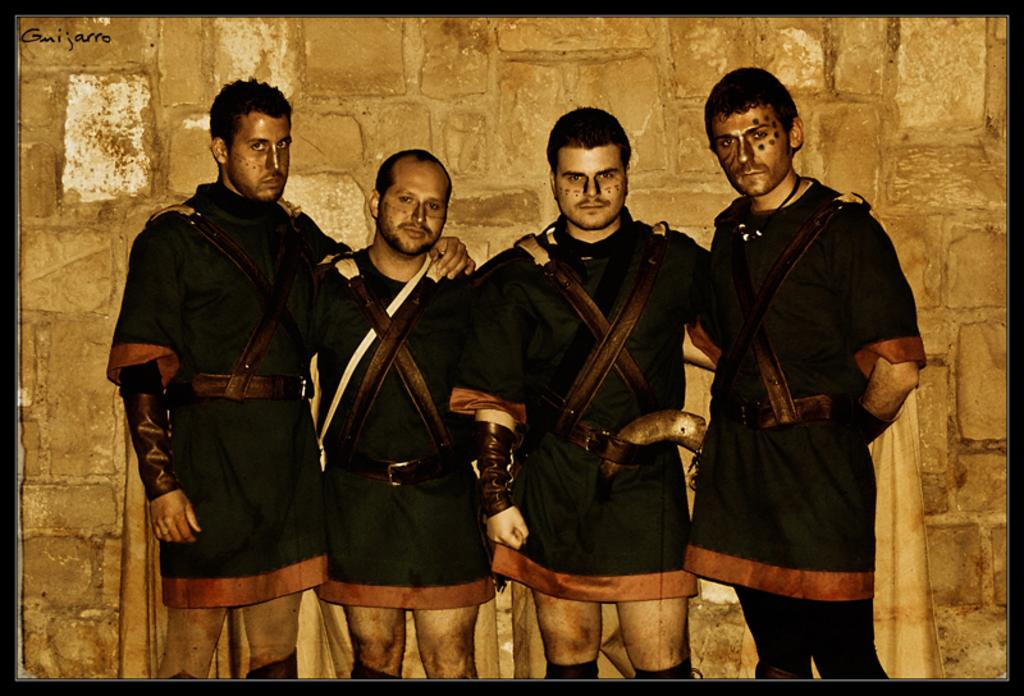How many people are present in the image? There are four men standing in the image. What can be seen in the top left corner of the image? There is text on the top left of the image. What type of structure is visible in the background of the image? There is a stone wall in the background of the image. What is the answer to the question that the men are discussing in the image? There is no indication in the image that the men are discussing a question or that there is an answer to be provided. 